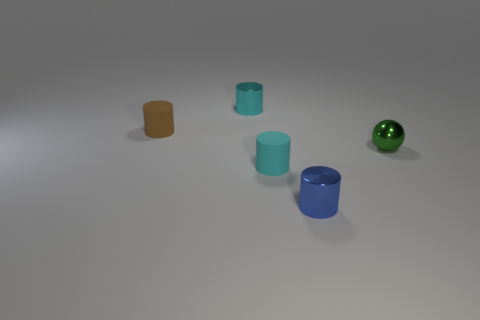Subtract all blue shiny cylinders. How many cylinders are left? 3 Subtract all cyan cylinders. How many cylinders are left? 2 Add 2 gray rubber things. How many objects exist? 7 Subtract all balls. How many objects are left? 4 Subtract 4 cylinders. How many cylinders are left? 0 Subtract all red spheres. Subtract all cyan cylinders. How many spheres are left? 1 Subtract all cyan balls. How many cyan cylinders are left? 2 Subtract all blue cylinders. Subtract all metallic objects. How many objects are left? 1 Add 5 small brown rubber objects. How many small brown rubber objects are left? 6 Add 2 small objects. How many small objects exist? 7 